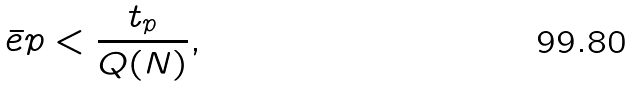Convert formula to latex. <formula><loc_0><loc_0><loc_500><loc_500>\bar { \ e p } < \frac { t _ { p } } { Q ( N ) } ,</formula> 